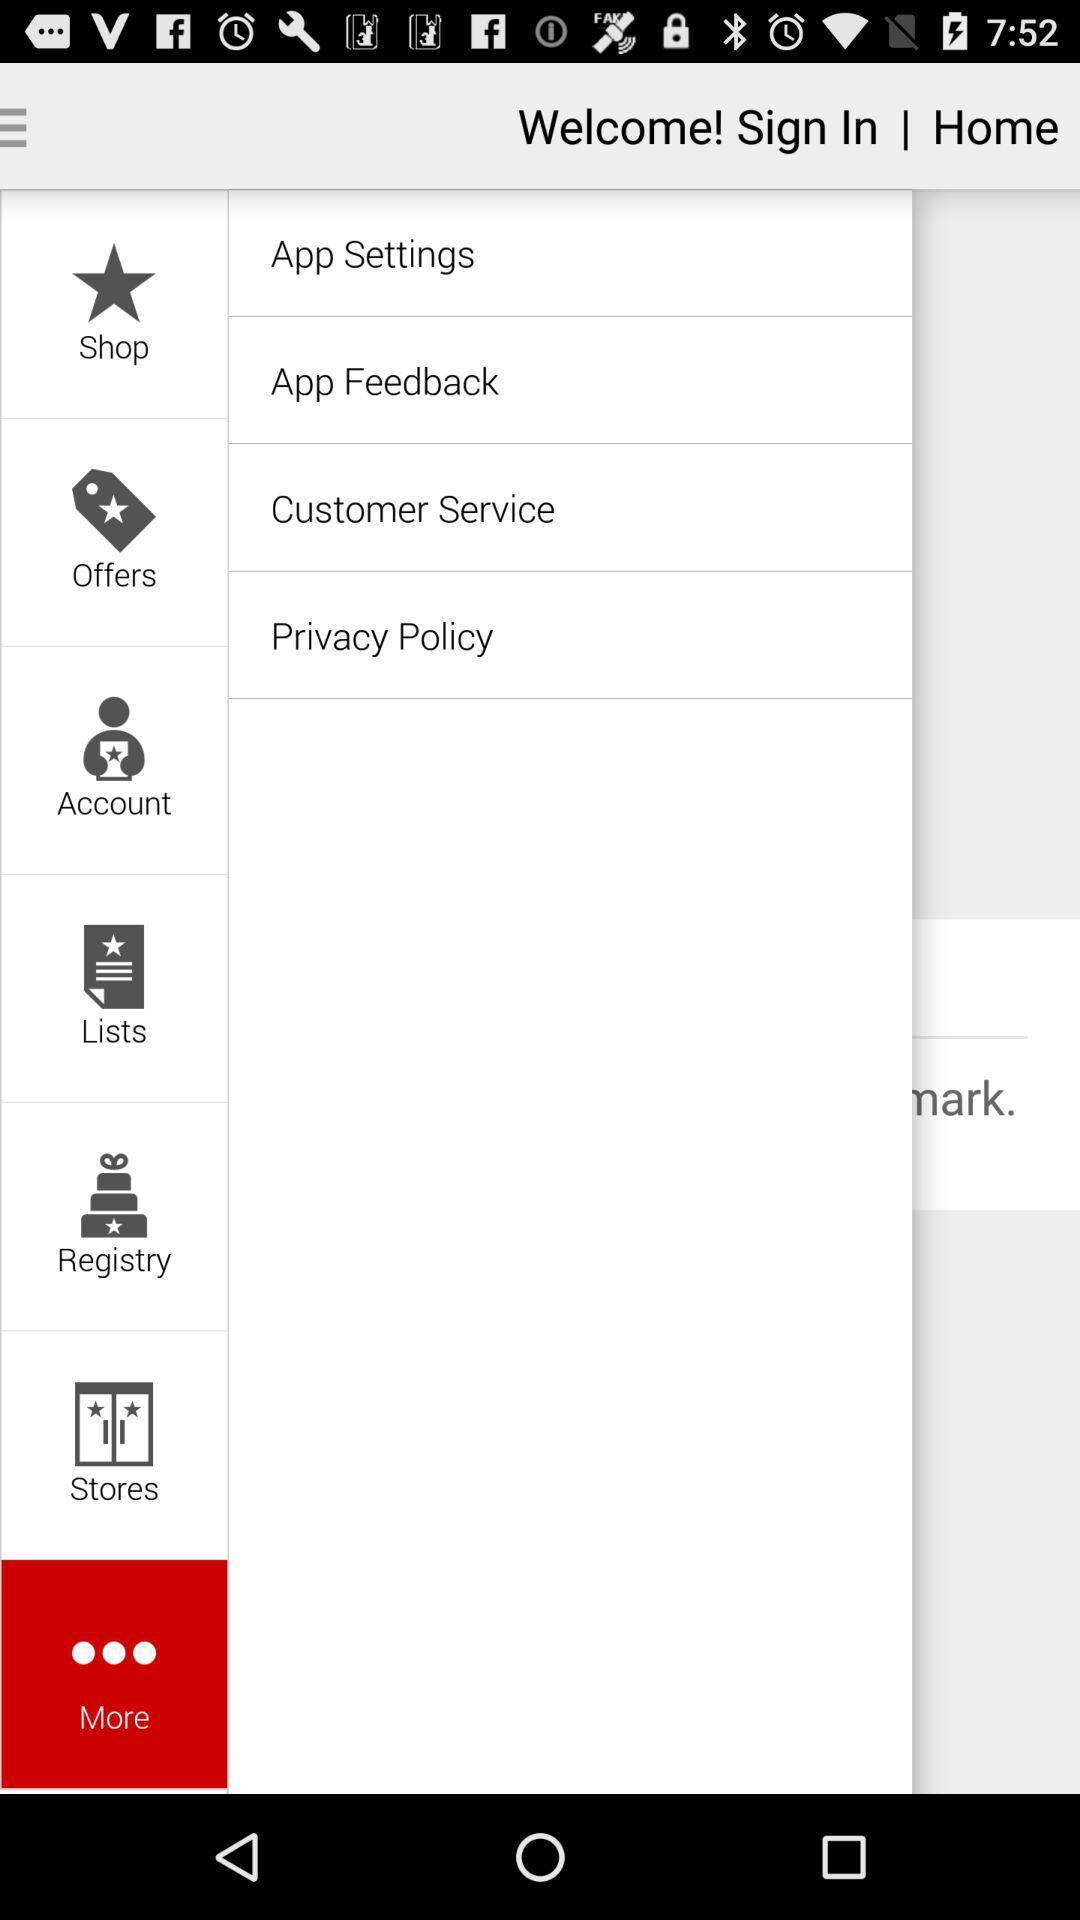Which option is selected? The selected option is "More". 